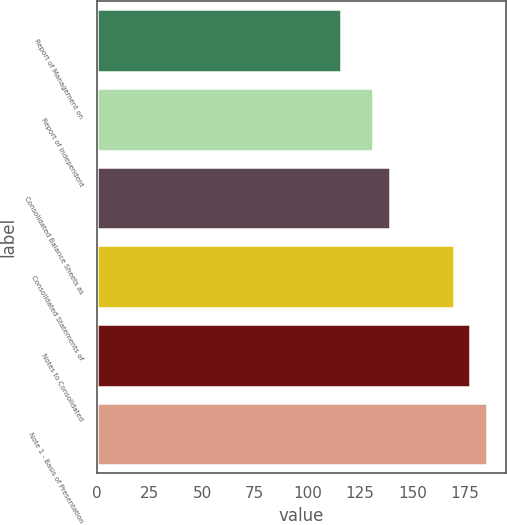Convert chart. <chart><loc_0><loc_0><loc_500><loc_500><bar_chart><fcel>Report of Management on<fcel>Report of Independent<fcel>Consolidated Balance Sheets as<fcel>Consolidated Statements of<fcel>Notes to Consolidated<fcel>Note 1 - Basis of Presentation<nl><fcel>116<fcel>131.4<fcel>139.1<fcel>169.9<fcel>177.6<fcel>185.3<nl></chart> 